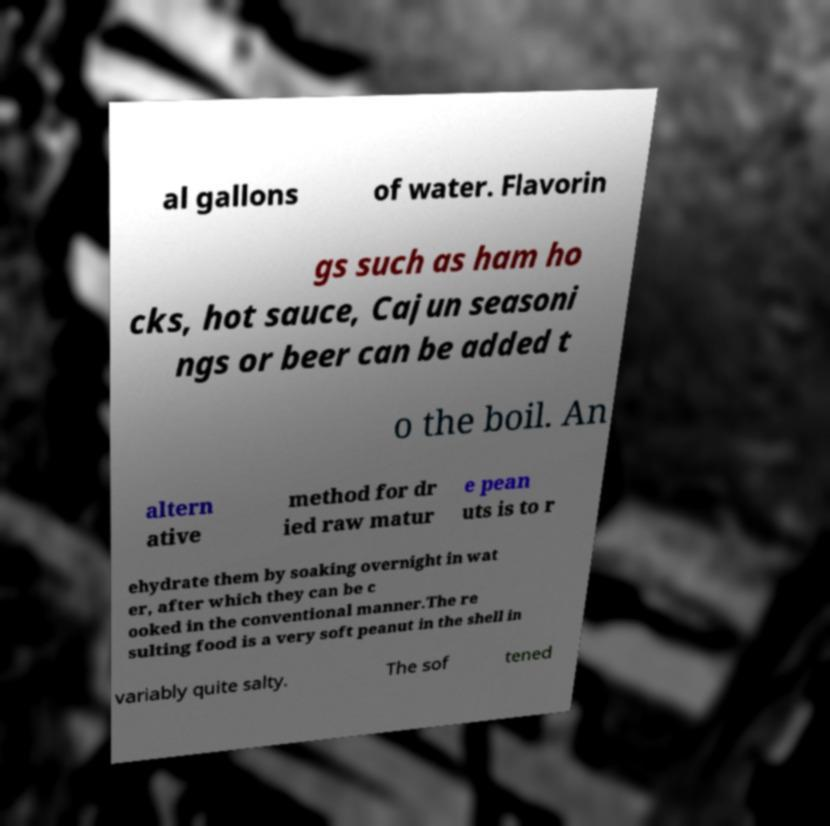Could you extract and type out the text from this image? al gallons of water. Flavorin gs such as ham ho cks, hot sauce, Cajun seasoni ngs or beer can be added t o the boil. An altern ative method for dr ied raw matur e pean uts is to r ehydrate them by soaking overnight in wat er, after which they can be c ooked in the conventional manner.The re sulting food is a very soft peanut in the shell in variably quite salty. The sof tened 